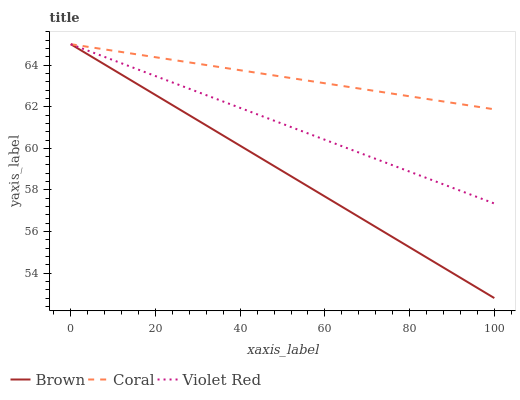Does Brown have the minimum area under the curve?
Answer yes or no. Yes. Does Coral have the maximum area under the curve?
Answer yes or no. Yes. Does Violet Red have the minimum area under the curve?
Answer yes or no. No. Does Violet Red have the maximum area under the curve?
Answer yes or no. No. Is Brown the smoothest?
Answer yes or no. Yes. Is Violet Red the roughest?
Answer yes or no. Yes. Is Coral the smoothest?
Answer yes or no. No. Is Coral the roughest?
Answer yes or no. No. Does Brown have the lowest value?
Answer yes or no. Yes. Does Violet Red have the lowest value?
Answer yes or no. No. Does Violet Red have the highest value?
Answer yes or no. Yes. Does Coral intersect Brown?
Answer yes or no. Yes. Is Coral less than Brown?
Answer yes or no. No. Is Coral greater than Brown?
Answer yes or no. No. 